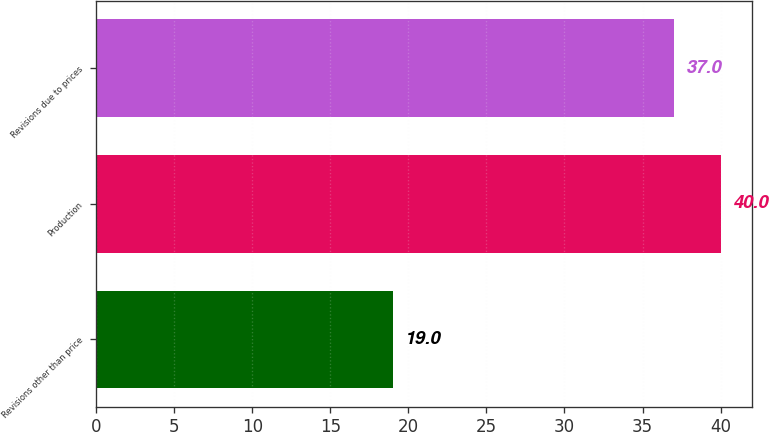Convert chart to OTSL. <chart><loc_0><loc_0><loc_500><loc_500><bar_chart><fcel>Revisions other than price<fcel>Production<fcel>Revisions due to prices<nl><fcel>19<fcel>40<fcel>37<nl></chart> 